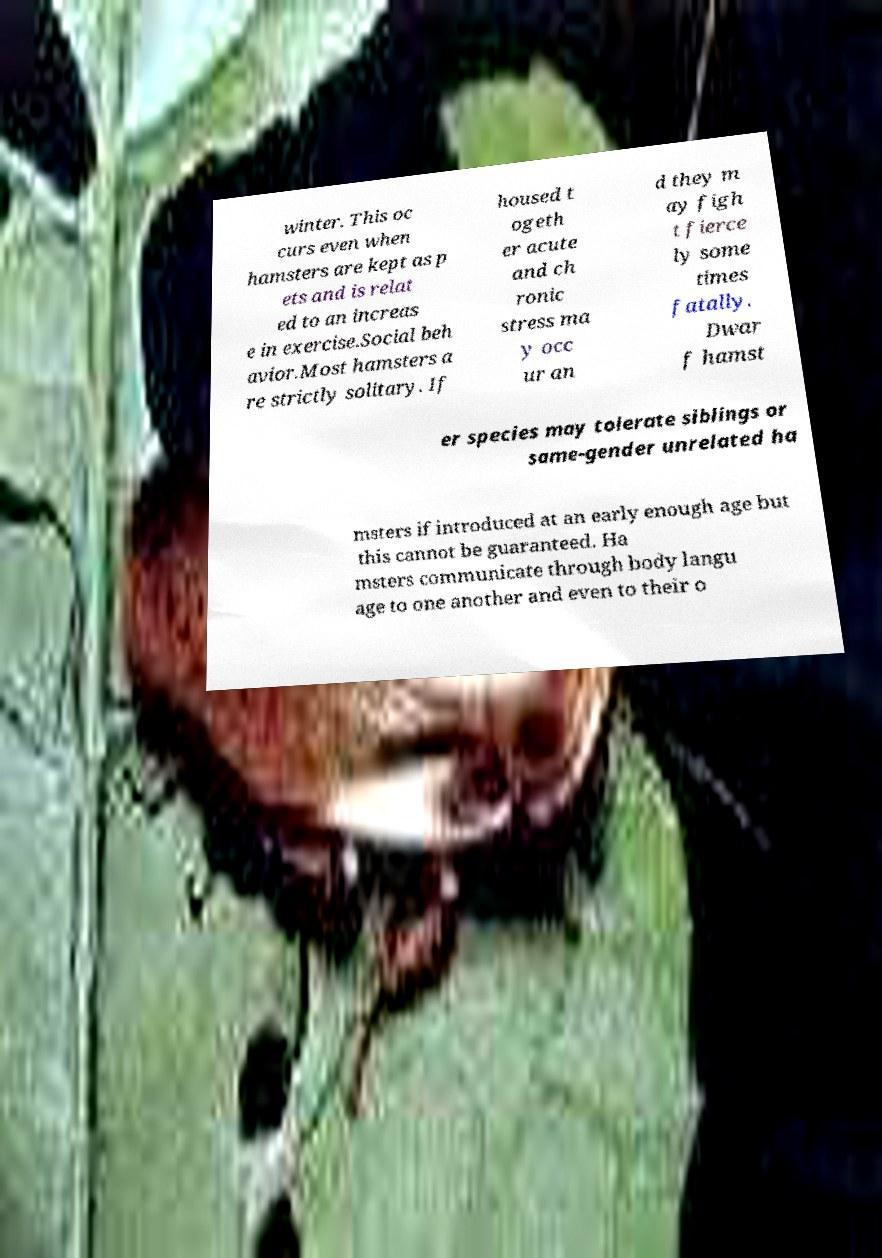Can you accurately transcribe the text from the provided image for me? winter. This oc curs even when hamsters are kept as p ets and is relat ed to an increas e in exercise.Social beh avior.Most hamsters a re strictly solitary. If housed t ogeth er acute and ch ronic stress ma y occ ur an d they m ay figh t fierce ly some times fatally. Dwar f hamst er species may tolerate siblings or same-gender unrelated ha msters if introduced at an early enough age but this cannot be guaranteed. Ha msters communicate through body langu age to one another and even to their o 